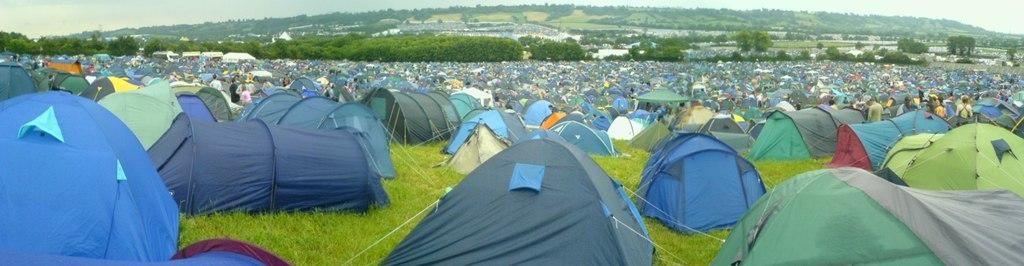What can be seen on the grass land in the image? There are many tents on the grass land in the image. What is visible in the background of the image? There is a hill visible in the background of the image. What is the hill covered with? The hill is covered with trees. What is visible above the hill? The sky is visible above the hill. What type of copper material can be seen in the image? There is no copper material present in the image. Where is the library located in the image? There is no library present in the image. 